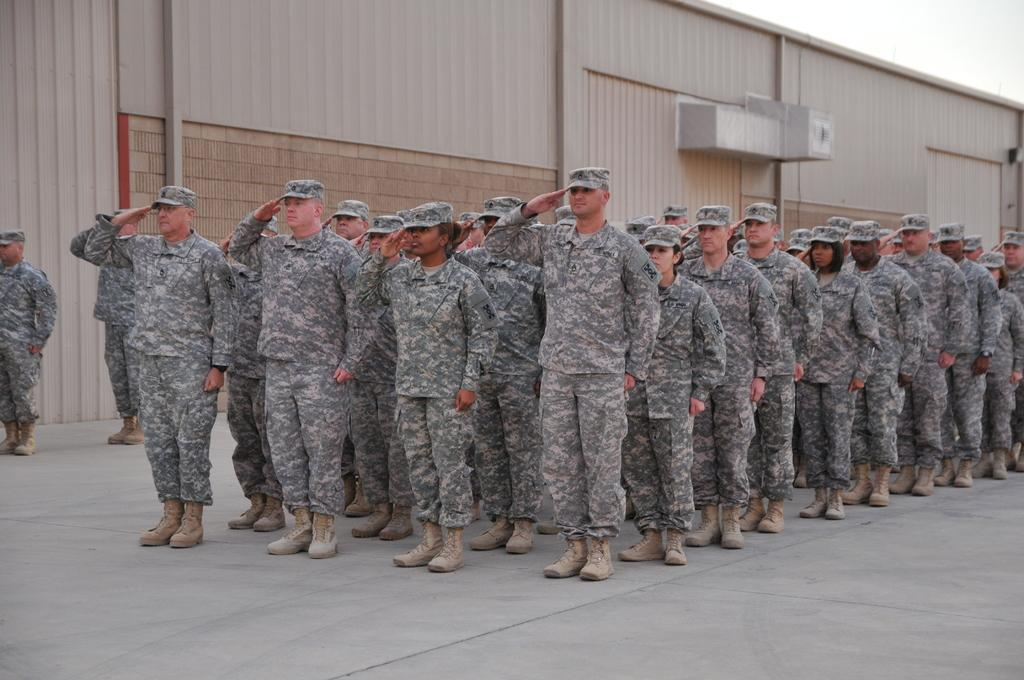What is the main subject of the image? The main subject of the image is a group of people. What type of clothing are the people wearing? The people are wearing military uniforms. What type of headwear are the people wearing? The people are wearing caps. Where are the people standing in the image? The people are standing on the floor. What can be seen in the background of the image? There is a building and the sky visible in the background of the image. What features can be observed on the building? The building has doors. What type of nail is being hammered into the head of the person in the image? There is no nail or hammering activity present in the image. 